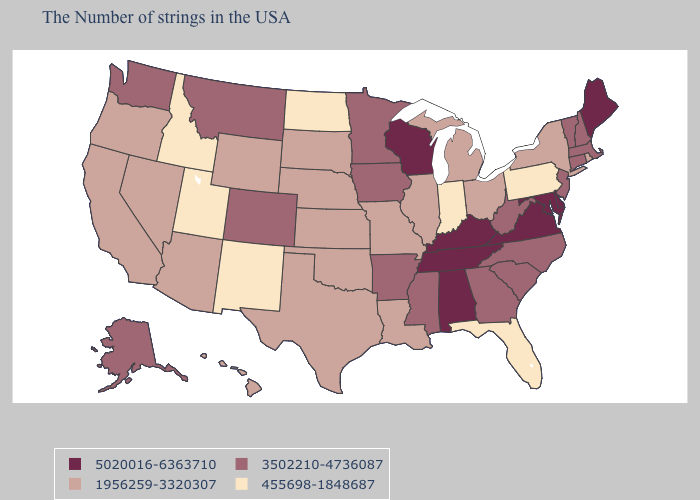Which states have the highest value in the USA?
Write a very short answer. Maine, Delaware, Maryland, Virginia, Kentucky, Alabama, Tennessee, Wisconsin. What is the lowest value in the USA?
Give a very brief answer. 455698-1848687. Does Minnesota have the highest value in the USA?
Answer briefly. No. Name the states that have a value in the range 455698-1848687?
Quick response, please. Pennsylvania, Florida, Indiana, North Dakota, New Mexico, Utah, Idaho. Does the map have missing data?
Quick response, please. No. Name the states that have a value in the range 455698-1848687?
Be succinct. Pennsylvania, Florida, Indiana, North Dakota, New Mexico, Utah, Idaho. Among the states that border Oklahoma , which have the lowest value?
Answer briefly. New Mexico. What is the lowest value in the West?
Quick response, please. 455698-1848687. Does Maine have the highest value in the USA?
Keep it brief. Yes. What is the highest value in states that border Vermont?
Quick response, please. 3502210-4736087. Among the states that border Arizona , does Colorado have the lowest value?
Quick response, please. No. How many symbols are there in the legend?
Give a very brief answer. 4. Name the states that have a value in the range 3502210-4736087?
Short answer required. Massachusetts, New Hampshire, Vermont, Connecticut, New Jersey, North Carolina, South Carolina, West Virginia, Georgia, Mississippi, Arkansas, Minnesota, Iowa, Colorado, Montana, Washington, Alaska. Among the states that border Michigan , does Ohio have the highest value?
Keep it brief. No. What is the lowest value in the USA?
Write a very short answer. 455698-1848687. 